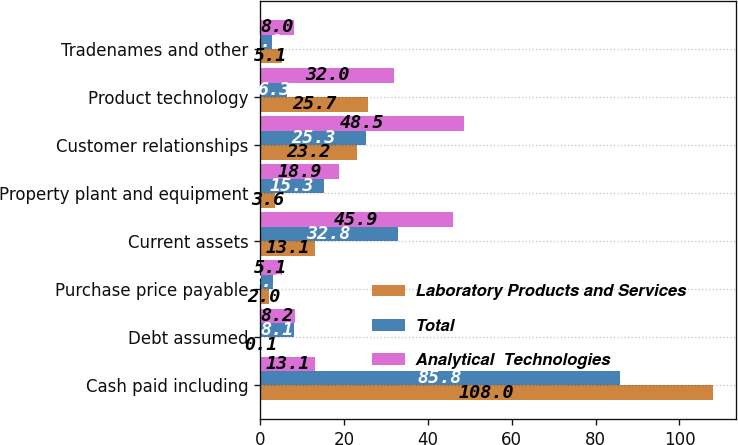Convert chart. <chart><loc_0><loc_0><loc_500><loc_500><stacked_bar_chart><ecel><fcel>Cash paid including<fcel>Debt assumed<fcel>Purchase price payable<fcel>Current assets<fcel>Property plant and equipment<fcel>Customer relationships<fcel>Product technology<fcel>Tradenames and other<nl><fcel>Laboratory Products and Services<fcel>108<fcel>0.1<fcel>2<fcel>13.1<fcel>3.6<fcel>23.2<fcel>25.7<fcel>5.1<nl><fcel>Total<fcel>85.8<fcel>8.1<fcel>3.1<fcel>32.8<fcel>15.3<fcel>25.3<fcel>6.3<fcel>2.9<nl><fcel>Analytical  Technologies<fcel>13.1<fcel>8.2<fcel>5.1<fcel>45.9<fcel>18.9<fcel>48.5<fcel>32<fcel>8<nl></chart> 